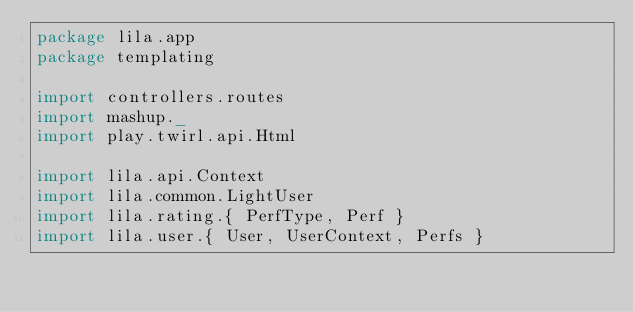<code> <loc_0><loc_0><loc_500><loc_500><_Scala_>package lila.app
package templating

import controllers.routes
import mashup._
import play.twirl.api.Html

import lila.api.Context
import lila.common.LightUser
import lila.rating.{ PerfType, Perf }
import lila.user.{ User, UserContext, Perfs }
</code> 